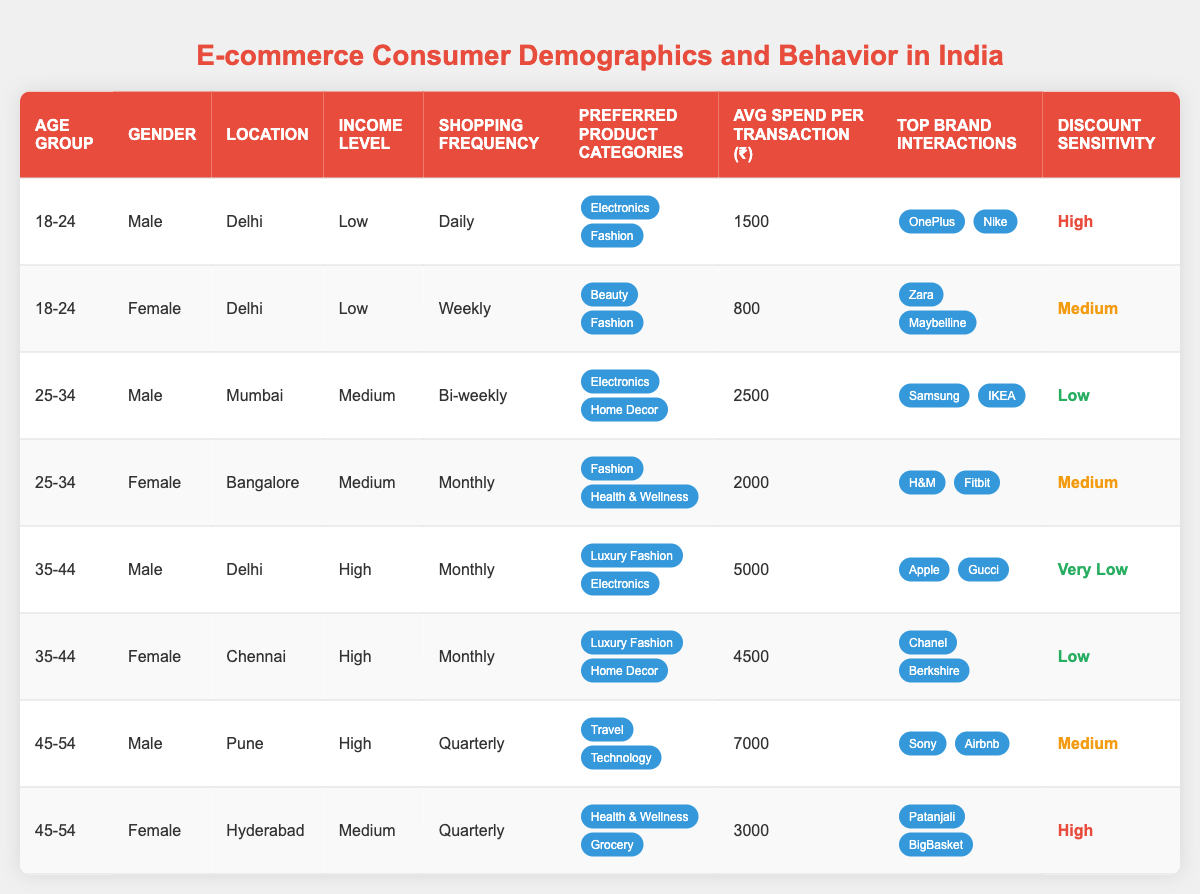What is the average spend per transaction for the age group 45-54? There are two data points for the age group 45-54: ₹7000 for males and ₹3000 for females. Adding them gives ₹7000 + ₹3000 = ₹10000. To find the average, divide by 2 data points: ₹10000 / 2 = ₹5000.
Answer: ₹5000 Which gender in the 35-44 age group has the highest average spend per transaction? For the 35-44 age group, males have an average spend of ₹5000, while females have an average spend of ₹4500. Comparing the two, males spend more on average.
Answer: Male How often do females in the age group 25-34 shop? The female in the age group 25-34 shops monthly according to the data provided in the table.
Answer: Monthly Are individuals in Mumbai generally more likely to be in a medium income level based on the table? Only one individual from Mumbai appears in the data, who is in the medium income level. Thus, we cannot conclude that individuals in Mumbai are generally of medium income level due to the lack of additional data points.
Answer: No What product categories do the females in the age group 18-24 prefer? The data shows that females in the age group 18-24 have a preference for Beauty and Fashion product categories.
Answer: Beauty and Fashion Which location has the highest average spend per transaction based on the table? The highest average spends per transaction are ₹7000 in Pune and ₹5000 in Delhi. Since Pune has the highest figure, it is the location with the highest average spend.
Answer: Pune Is there any male shopper with very low discount sensitivity in the table? Yes, the male in the age group 35-44 from Delhi has very low discount sensitivity as indicated in the data.
Answer: Yes What is the total average spend per transaction for females across all age groups? The females in the data have average spends of ₹800 (18-24), ₹2000 (25-34), ₹4500 (35-44), and ₹3000 (45-54). Totaling these gives ₹800 + ₹2000 + ₹4500 + ₹3000 = ₹10300. There are 4 females, so to find the average: ₹10300 / 4 = ₹2575.
Answer: ₹2575 How many shoppers are from the low income level in the age group 18-24? There are two shoppers in the age group 18-24, both of whom are classified as low income: one male and one female. Thus, there are 2 shoppers from low income in this age group.
Answer: 2 Are males more likely to shop daily compared to females according to the table? Looking at the data, only one male from the age group 18-24 shops daily, while no females shop daily. Therefore, males are more likely to shop daily compared to females in this dataset.
Answer: Yes 